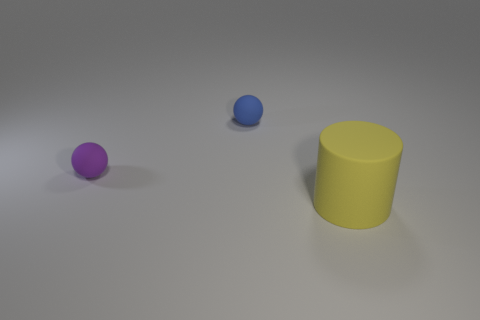Add 1 green metallic blocks. How many objects exist? 4 Subtract 0 green spheres. How many objects are left? 3 Subtract all balls. How many objects are left? 1 Subtract all tiny blue things. Subtract all small objects. How many objects are left? 0 Add 3 blue matte objects. How many blue matte objects are left? 4 Add 1 large yellow rubber objects. How many large yellow rubber objects exist? 2 